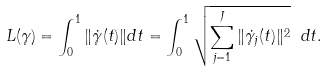<formula> <loc_0><loc_0><loc_500><loc_500>L ( \gamma ) = \int _ { 0 } ^ { 1 } \| \dot { \gamma } ( t ) \| d t = \int _ { 0 } ^ { 1 } \sqrt { \sum _ { j = 1 } ^ { J } \| \dot { \gamma _ { j } } ( t ) \| ^ { 2 } } \ d t .</formula> 